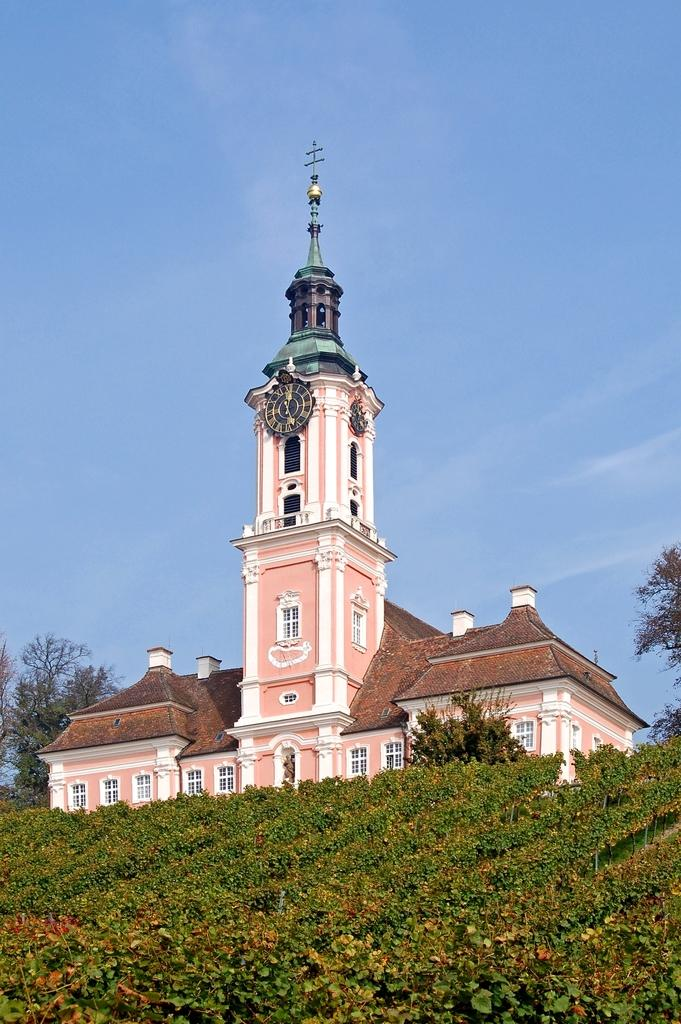What type of vegetation is present in the image? There is grass and plants in the image. What type of structure is visible in the image? There is a building in the image. What else can be seen in the image besides the building? There are trees in the image. What part of the natural environment is visible in the image? The sky is visible in the image. Based on the presence of the sky and the absence of artificial lighting, when do you think the image was taken? The image was likely taken during the day. What type of underwear is hanging on the tree in the image? There is no underwear present in the image; it only features grass, plants, a building, trees, and the sky. What type of school is visible in the image? There is no school present in the image. Is there a gun visible in the image? No, there is no gun present in the image. 